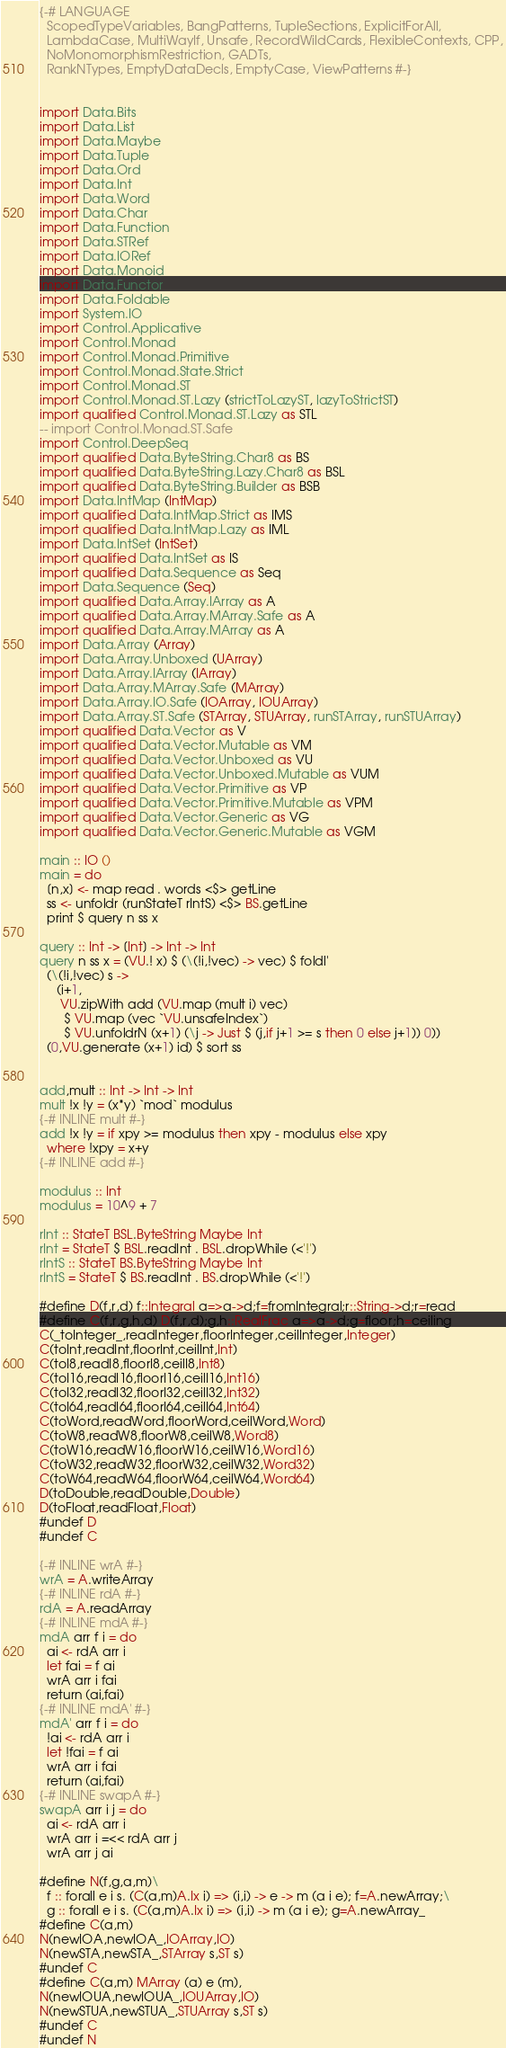<code> <loc_0><loc_0><loc_500><loc_500><_Haskell_>{-# LANGUAGE
  ScopedTypeVariables, BangPatterns, TupleSections, ExplicitForAll,
  LambdaCase, MultiWayIf, Unsafe, RecordWildCards, FlexibleContexts, CPP,
  NoMonomorphismRestriction, GADTs,
  RankNTypes, EmptyDataDecls, EmptyCase, ViewPatterns #-}


import Data.Bits
import Data.List
import Data.Maybe
import Data.Tuple
import Data.Ord
import Data.Int
import Data.Word
import Data.Char
import Data.Function
import Data.STRef
import Data.IORef
import Data.Monoid
import Data.Functor
import Data.Foldable 
import System.IO
import Control.Applicative
import Control.Monad
import Control.Monad.Primitive
import Control.Monad.State.Strict
import Control.Monad.ST
import Control.Monad.ST.Lazy (strictToLazyST, lazyToStrictST)
import qualified Control.Monad.ST.Lazy as STL
-- import Control.Monad.ST.Safe
import Control.DeepSeq
import qualified Data.ByteString.Char8 as BS
import qualified Data.ByteString.Lazy.Char8 as BSL
import qualified Data.ByteString.Builder as BSB
import Data.IntMap (IntMap)
import qualified Data.IntMap.Strict as IMS
import qualified Data.IntMap.Lazy as IML
import Data.IntSet (IntSet)
import qualified Data.IntSet as IS
import qualified Data.Sequence as Seq
import Data.Sequence (Seq)
import qualified Data.Array.IArray as A
import qualified Data.Array.MArray.Safe as A
import qualified Data.Array.MArray as A
import Data.Array (Array)
import Data.Array.Unboxed (UArray)
import Data.Array.IArray (IArray)
import Data.Array.MArray.Safe (MArray)
import Data.Array.IO.Safe (IOArray, IOUArray)
import Data.Array.ST.Safe (STArray, STUArray, runSTArray, runSTUArray)
import qualified Data.Vector as V
import qualified Data.Vector.Mutable as VM
import qualified Data.Vector.Unboxed as VU
import qualified Data.Vector.Unboxed.Mutable as VUM
import qualified Data.Vector.Primitive as VP
import qualified Data.Vector.Primitive.Mutable as VPM
import qualified Data.Vector.Generic as VG
import qualified Data.Vector.Generic.Mutable as VGM

main :: IO ()
main = do
  [n,x] <- map read . words <$> getLine
  ss <- unfoldr (runStateT rIntS) <$> BS.getLine
  print $ query n ss x

query :: Int -> [Int] -> Int -> Int
query n ss x = (VU.! x) $ (\(!i,!vec) -> vec) $ foldl'
  (\(!i,!vec) s ->
     (i+1,
      VU.zipWith add (VU.map (mult i) vec)
       $ VU.map (vec `VU.unsafeIndex`)
       $ VU.unfoldrN (x+1) (\j -> Just $ (j,if j+1 >= s then 0 else j+1)) 0))
  (0,VU.generate (x+1) id) $ sort ss


add,mult :: Int -> Int -> Int
mult !x !y = (x*y) `mod` modulus
{-# INLINE mult #-}
add !x !y = if xpy >= modulus then xpy - modulus else xpy
  where !xpy = x+y
{-# INLINE add #-}
            
modulus :: Int
modulus = 10^9 + 7

rInt :: StateT BSL.ByteString Maybe Int
rInt = StateT $ BSL.readInt . BSL.dropWhile (<'!')
rIntS :: StateT BS.ByteString Maybe Int
rIntS = StateT $ BS.readInt . BS.dropWhile (<'!')

#define D(f,r,d) f::Integral a=>a->d;f=fromIntegral;r::String->d;r=read
#define C(f,r,g,h,d) D(f,r,d);g,h::RealFrac a=>a->d;g=floor;h=ceiling
C(_toInteger_,readInteger,floorInteger,ceilInteger,Integer)
C(toInt,readInt,floorInt,ceilInt,Int)
C(toI8,readI8,floorI8,ceilI8,Int8)
C(toI16,readI16,floorI16,ceilI16,Int16)
C(toI32,readI32,floorI32,ceilI32,Int32)
C(toI64,readI64,floorI64,ceilI64,Int64)
C(toWord,readWord,floorWord,ceilWord,Word)
C(toW8,readW8,floorW8,ceilW8,Word8)
C(toW16,readW16,floorW16,ceilW16,Word16)
C(toW32,readW32,floorW32,ceilW32,Word32)
C(toW64,readW64,floorW64,ceilW64,Word64)
D(toDouble,readDouble,Double)
D(toFloat,readFloat,Float)
#undef D
#undef C

{-# INLINE wrA #-}
wrA = A.writeArray
{-# INLINE rdA #-}
rdA = A.readArray
{-# INLINE mdA #-}
mdA arr f i = do
  ai <- rdA arr i
  let fai = f ai 
  wrA arr i fai
  return (ai,fai)
{-# INLINE mdA' #-}
mdA' arr f i = do
  !ai <- rdA arr i
  let !fai = f ai
  wrA arr i fai
  return (ai,fai)
{-# INLINE swapA #-}
swapA arr i j = do
  ai <- rdA arr i
  wrA arr i =<< rdA arr j
  wrA arr j ai

#define N(f,g,a,m)\
  f :: forall e i s. (C(a,m)A.Ix i) => (i,i) -> e -> m (a i e); f=A.newArray;\
  g :: forall e i s. (C(a,m)A.Ix i) => (i,i) -> m (a i e); g=A.newArray_
#define C(a,m)
N(newIOA,newIOA_,IOArray,IO)
N(newSTA,newSTA_,STArray s,ST s)
#undef C
#define C(a,m) MArray (a) e (m), 
N(newIOUA,newIOUA_,IOUArray,IO)
N(newSTUA,newSTUA_,STUArray s,ST s)
#undef C
#undef N

</code> 